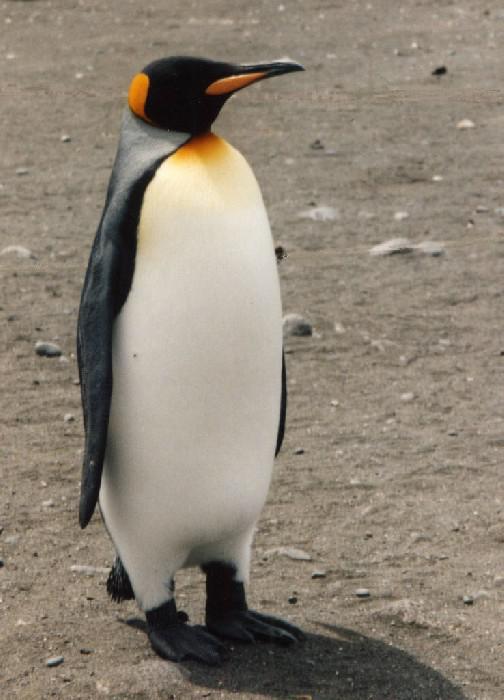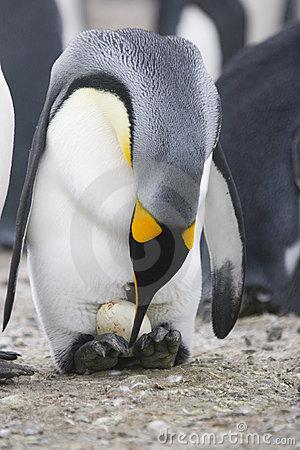The first image is the image on the left, the second image is the image on the right. Assess this claim about the two images: "There are four penguins". Correct or not? Answer yes or no. No. 